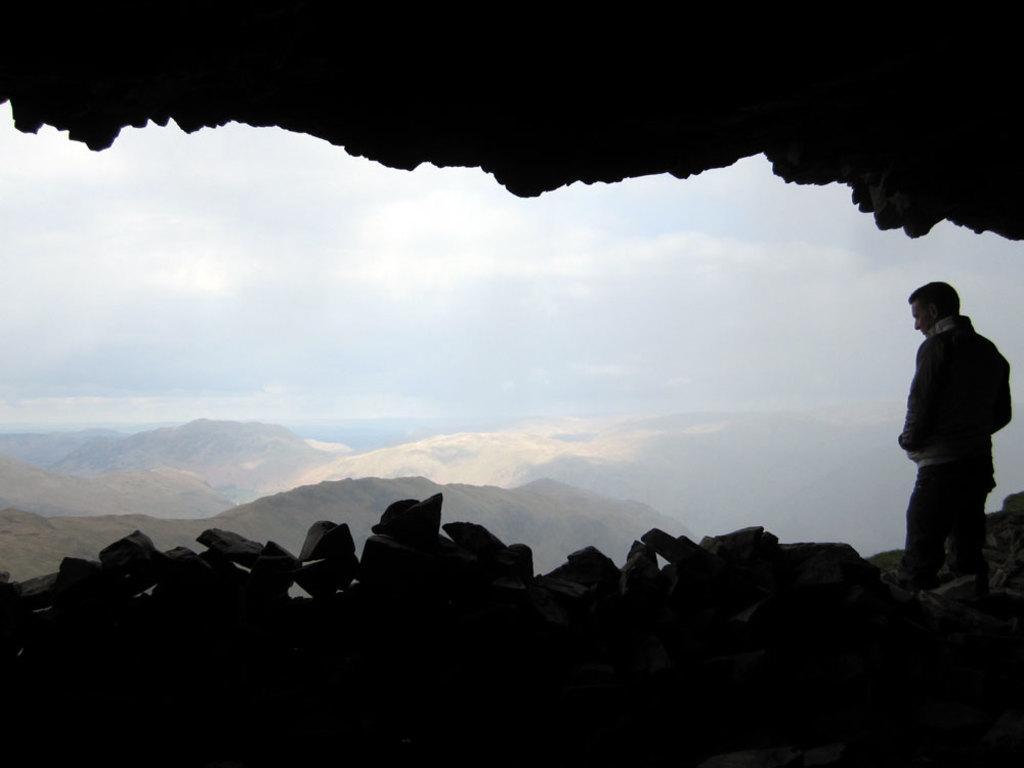Describe this image in one or two sentences. In this picture we can see a person standing on the right side. There are few rocks and mountains in the background. Sky is cloudy. 